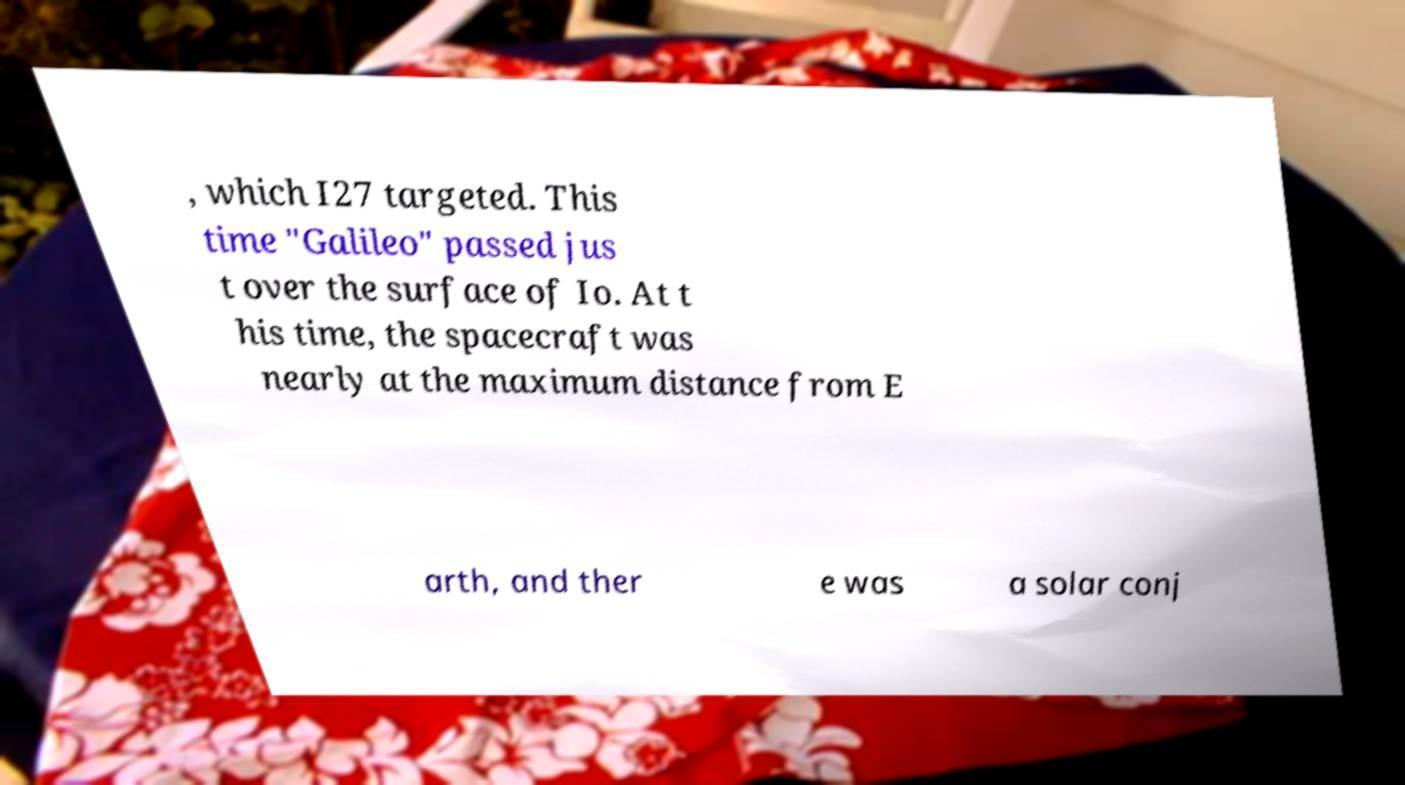I need the written content from this picture converted into text. Can you do that? , which I27 targeted. This time "Galileo" passed jus t over the surface of Io. At t his time, the spacecraft was nearly at the maximum distance from E arth, and ther e was a solar conj 